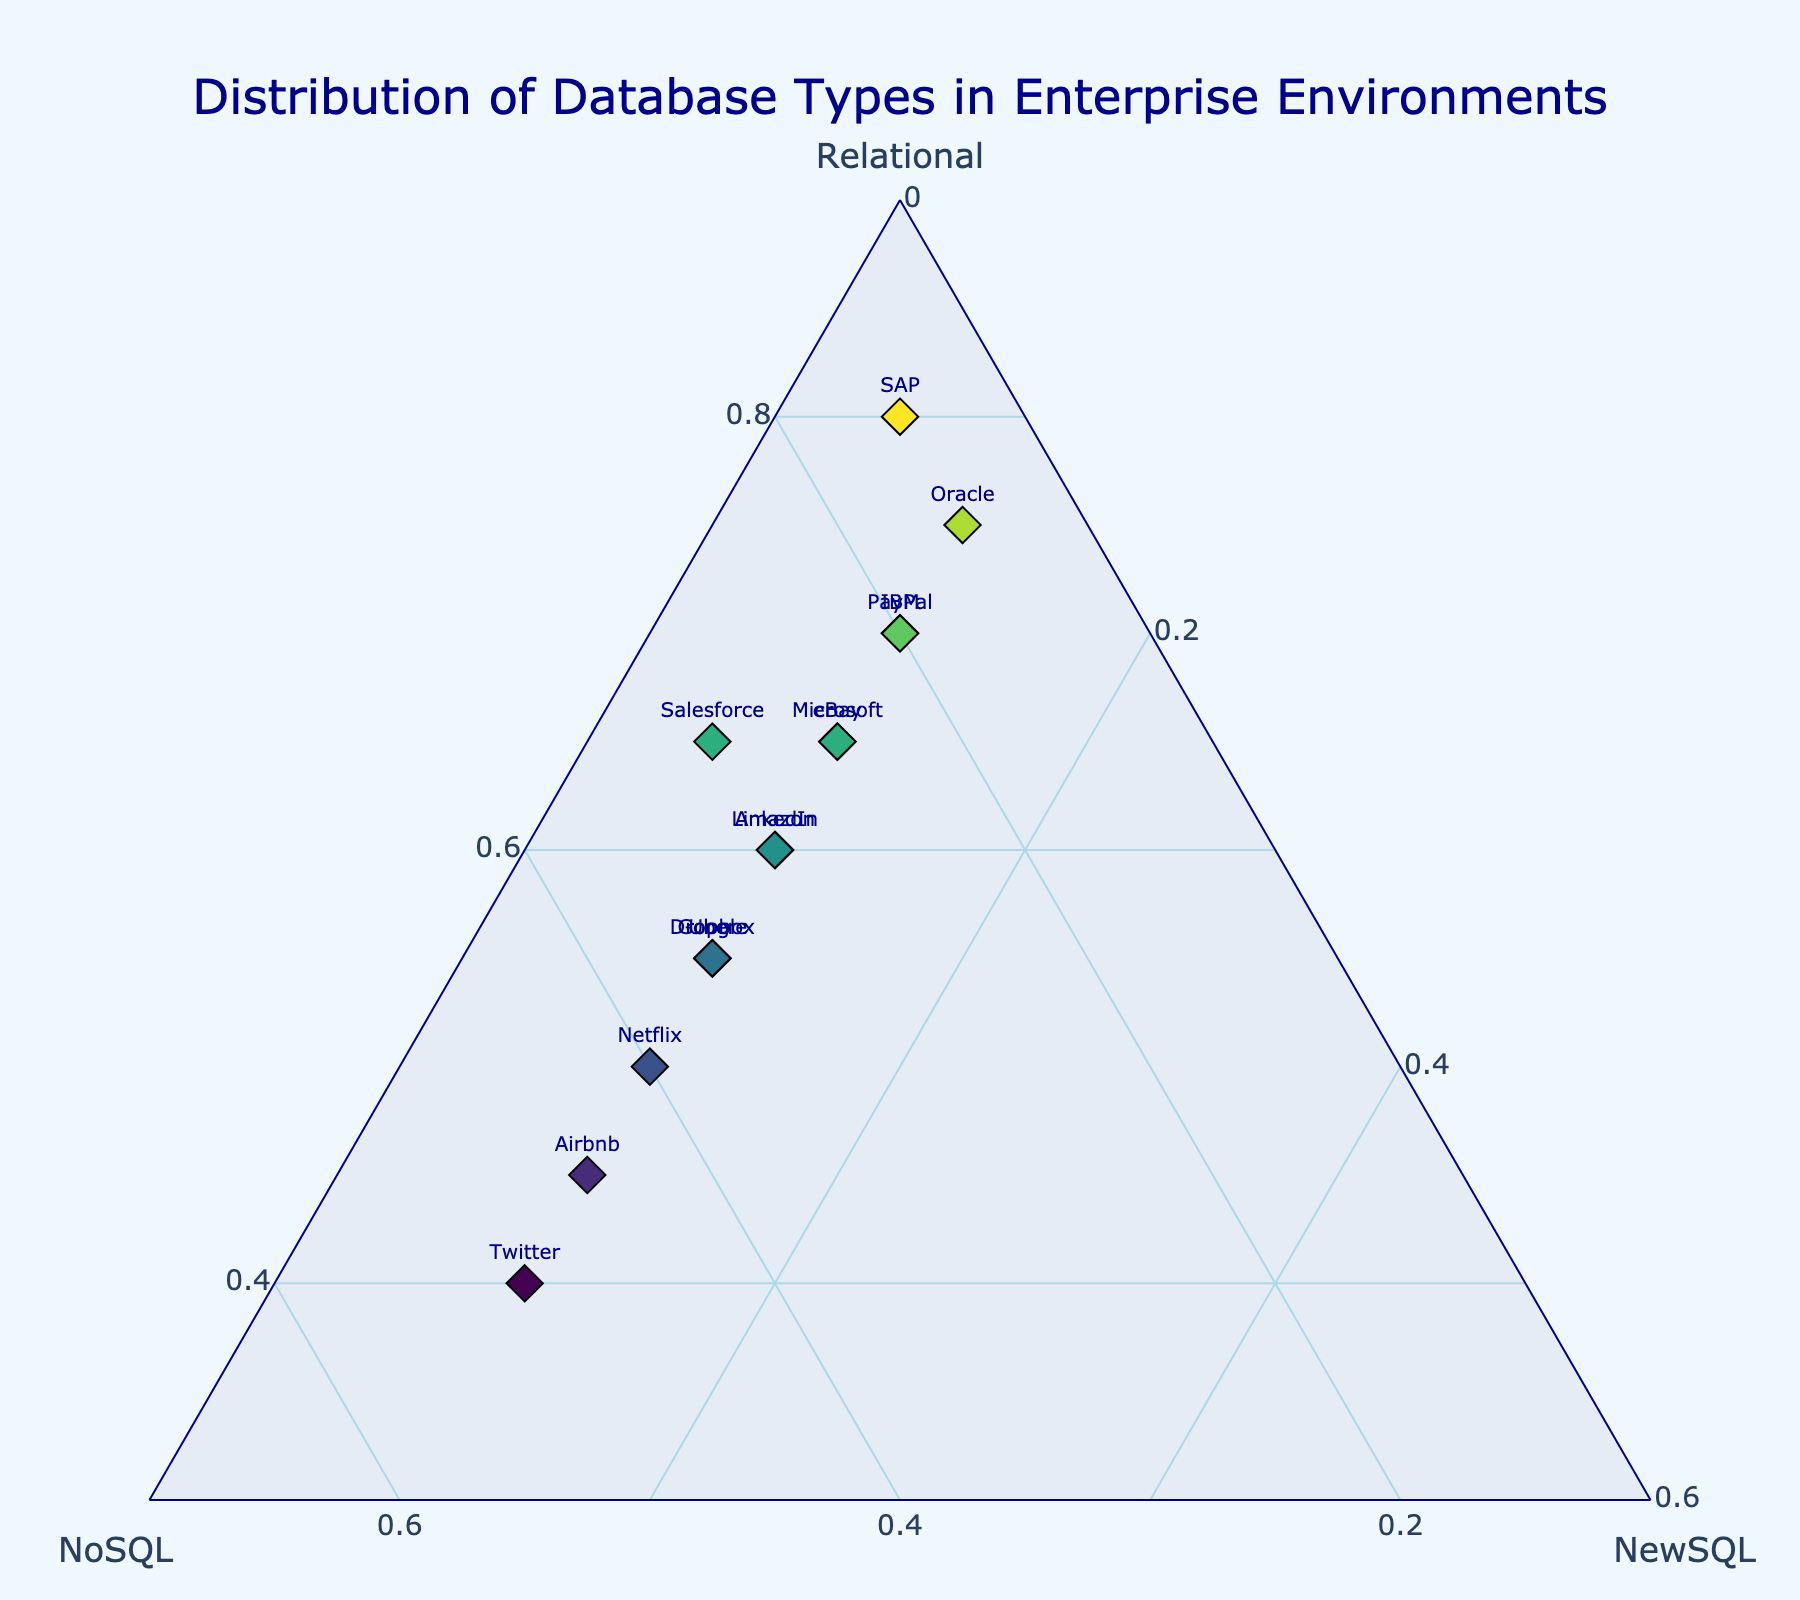What's the title of the figure? The title is displayed at the top center of the figure, making it easy to see and understand the overall content of the plot.
Answer: Distribution of Database Types in Enterprise Environments How many companies have more NoSQL than Relational databases? To find this, look at the points on the ternary plot where the NoSQL percentage is higher than the Relational percentage. Count these points by observing their position.
Answer: 3 (Netflix, Airbnb, Twitter) Which company has the highest proportion of Relational databases? Find the point that is closest to the vertex labeled "Relational" on the plot. The text label at this point will indicate the company.
Answer: SAP What is the common proportion of NewSQL across all companies? The text on the plot shows percentages for Relational, NoSQL, and NewSQL. Checking multiple points, we see NewSQL is consistently around 10%, except for a few companies.
Answer: 10% Between Amazon and Microsoft, which has a higher proportion of NoSQL databases? Locate both companies on the plot and compare their positions relative to the NoSQL vertex. The one closer to the NoSQL vertex has a higher proportion of NoSQL.
Answer: Amazon Which company has an equal proportion of Relational and NoSQL databases? An equal proportion of Relational and NoSQL would mean a point lying along the axis between these two vertices. Identify the text label at this point.
Answer: Airbnb What is the approximate average proportion of Relational databases for all companies? Sum the Relational percentages for all companies and divide by the number of companies (15). (60 + 65 + 55 + 70 + 75 + 80 + 65 + 50 + 55 + 45 + 40 + 60 + 70 + 65 + 55) / 15 ≈ 61.3%.
Answer: 61.3% Which company has the smallest proportion of NewSQL databases? Find the point farthest from the NewSQL vertex and check the text label of that point.
Answer: SAP Are there any companies that have the same proportions of all three types of databases? Check if there is a point located at the center of the plot, where Relational, NoSQL, and NewSQL are equal (33.33%). There is no text indicating this.
Answer: No How do the proportions of database types in Oracle compare to those in PayPal? Look at the positions of Oracle and PayPal. Oracle has 75% Relational, 15% NoSQL, and 10% NewSQL, while PayPal has 70% Relational, 20% NoSQL, and 10% NewSQL. Compare these values.
Answer: Oracle has more Relational and less NoSQL than PayPal, same NewSQL 